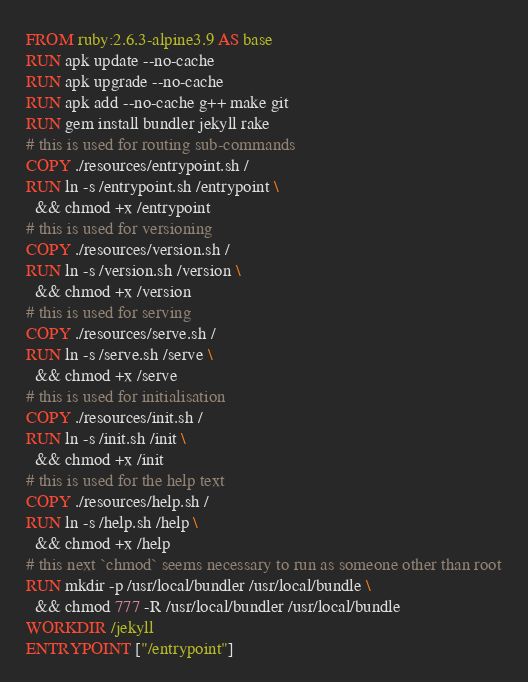<code> <loc_0><loc_0><loc_500><loc_500><_Dockerfile_>FROM ruby:2.6.3-alpine3.9 AS base
RUN apk update --no-cache
RUN apk upgrade --no-cache
RUN apk add --no-cache g++ make git
RUN gem install bundler jekyll rake
# this is used for routing sub-commands
COPY ./resources/entrypoint.sh /
RUN ln -s /entrypoint.sh /entrypoint \
  && chmod +x /entrypoint
# this is used for versioning
COPY ./resources/version.sh /
RUN ln -s /version.sh /version \
  && chmod +x /version
# this is used for serving
COPY ./resources/serve.sh /
RUN ln -s /serve.sh /serve \
  && chmod +x /serve
# this is used for initialisation
COPY ./resources/init.sh /
RUN ln -s /init.sh /init \
  && chmod +x /init
# this is used for the help text
COPY ./resources/help.sh /
RUN ln -s /help.sh /help \
  && chmod +x /help
# this next `chmod` seems necessary to run as someone other than root
RUN mkdir -p /usr/local/bundler /usr/local/bundle \
  && chmod 777 -R /usr/local/bundler /usr/local/bundle
WORKDIR /jekyll
ENTRYPOINT ["/entrypoint"]
</code> 